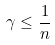<formula> <loc_0><loc_0><loc_500><loc_500>\gamma \leq \frac { 1 } { n }</formula> 